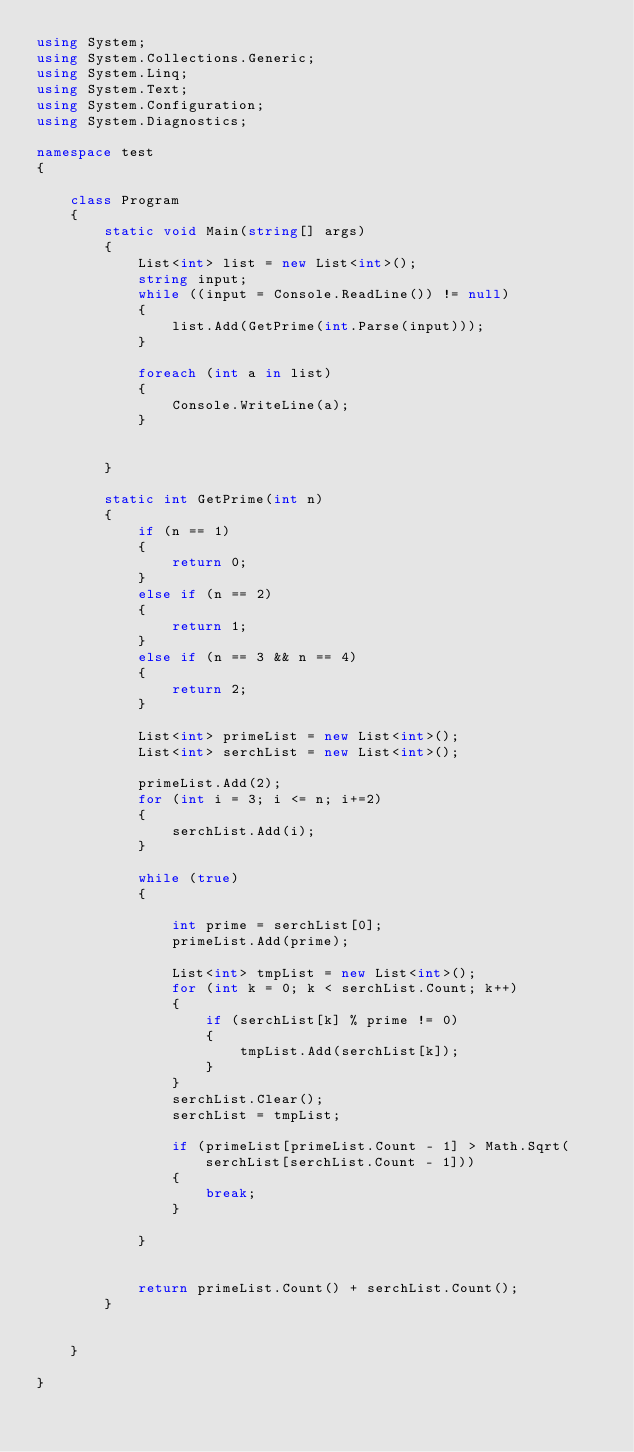Convert code to text. <code><loc_0><loc_0><loc_500><loc_500><_C#_>using System;
using System.Collections.Generic;
using System.Linq;
using System.Text;
using System.Configuration;
using System.Diagnostics;

namespace test
{

    class Program
    {
        static void Main(string[] args)
        {
            List<int> list = new List<int>();
            string input;
            while ((input = Console.ReadLine()) != null)
            {
                list.Add(GetPrime(int.Parse(input)));
            }

            foreach (int a in list)
            {
                Console.WriteLine(a);
            }


        }

        static int GetPrime(int n)
        {
            if (n == 1)
            {
                return 0;
            }
            else if (n == 2)
            {
                return 1;
            }
            else if (n == 3 && n == 4)
            {
                return 2;
            }

            List<int> primeList = new List<int>();
            List<int> serchList = new List<int>();

            primeList.Add(2);
            for (int i = 3; i <= n; i+=2)
            {
                serchList.Add(i);
            }

            while (true)
            {

                int prime = serchList[0];
                primeList.Add(prime);

                List<int> tmpList = new List<int>();
                for (int k = 0; k < serchList.Count; k++)
                {
                    if (serchList[k] % prime != 0)
                    {
                        tmpList.Add(serchList[k]);
                    }
                }
                serchList.Clear();
                serchList = tmpList;

                if (primeList[primeList.Count - 1] > Math.Sqrt(serchList[serchList.Count - 1]))
                {
                    break;
                }

            }


            return primeList.Count() + serchList.Count();
        }
        

    }
        
}</code> 